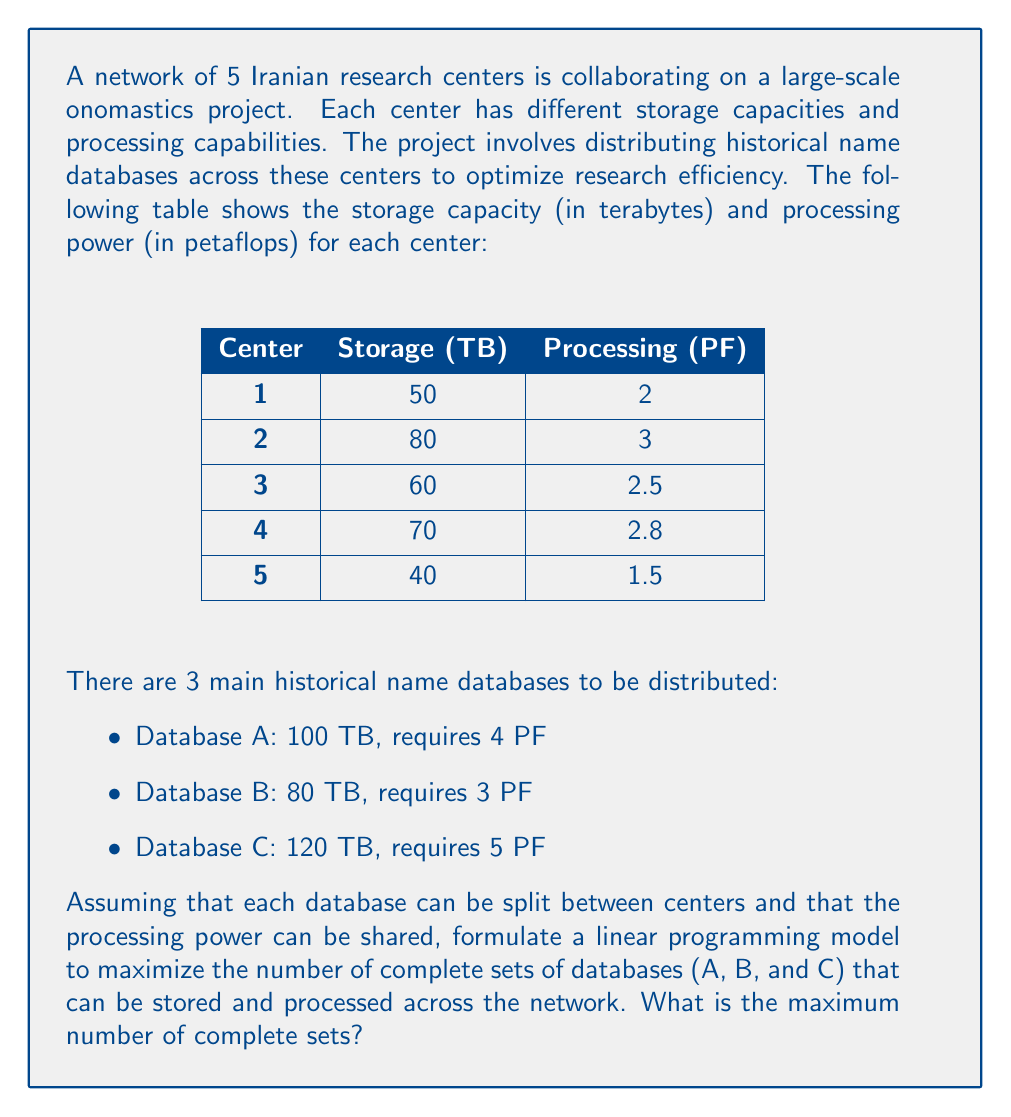What is the answer to this math problem? To solve this problem, we need to formulate a linear programming model and then solve it. Let's go through this step-by-step:

1) Define variables:
   Let $x_i$ be the number of complete sets stored and processed at center $i$ (where $i = 1, 2, 3, 4, 5$)

2) Objective function:
   Maximize the total number of complete sets:
   $$\text{Maximize } Z = x_1 + x_2 + x_3 + x_4 + x_5$$

3) Constraints:
   a) Storage constraints for each center:
      Center 1: $100x_1 + 80x_1 + 120x_1 \leq 50$
      Center 2: $100x_2 + 80x_2 + 120x_2 \leq 80$
      Center 3: $100x_3 + 80x_3 + 120x_3 \leq 60$
      Center 4: $100x_4 + 80x_4 + 120x_4 \leq 70$
      Center 5: $100x_5 + 80x_5 + 120x_5 \leq 40$

   b) Processing power constraints for each center:
      Center 1: $4x_1 + 3x_1 + 5x_1 \leq 2$
      Center 2: $4x_2 + 3x_2 + 5x_2 \leq 3$
      Center 3: $4x_3 + 3x_3 + 5x_3 \leq 2.5$
      Center 4: $4x_4 + 3x_4 + 5x_4 \leq 2.8$
      Center 5: $4x_5 + 3x_5 + 5x_5 \leq 1.5$

   c) Non-negativity constraints:
      $x_1, x_2, x_3, x_4, x_5 \geq 0$

4) Simplify the constraints:
   a) Storage constraints:
      Center 1: $300x_1 \leq 50$
      Center 2: $300x_2 \leq 80$
      Center 3: $300x_3 \leq 60$
      Center 4: $300x_4 \leq 70$
      Center 5: $300x_5 \leq 40$

   b) Processing power constraints:
      Center 1: $12x_1 \leq 2$
      Center 2: $12x_2 \leq 3$
      Center 3: $12x_3 \leq 2.5$
      Center 4: $12x_4 \leq 2.8$
      Center 5: $12x_5 \leq 1.5$

5) Solve the linear programming problem:
   We can solve this by looking at the most restrictive constraint for each center:

   Center 1: $x_1 \leq \min(\frac{50}{300}, \frac{2}{12}) = \frac{1}{6}$
   Center 2: $x_2 \leq \min(\frac{80}{300}, \frac{3}{12}) = \frac{1}{4}$
   Center 3: $x_3 \leq \min(\frac{60}{300}, \frac{2.5}{12}) = \frac{25}{144} \approx 0.1736$
   Center 4: $x_4 \leq \min(\frac{70}{300}, \frac{2.8}{12}) = \frac{7}{30} \approx 0.2333$
   Center 5: $x_5 \leq \min(\frac{40}{300}, \frac{1.5}{12}) = \frac{1}{8}$

   The maximum value of Z is the sum of these upper bounds:
   $$Z = \frac{1}{6} + \frac{1}{4} + \frac{25}{144} + \frac{7}{30} + \frac{1}{8} \approx 0.9403$$

   Since we can only have whole sets, we round down to 0.
Answer: The maximum number of complete sets of databases (A, B, and C) that can be stored and processed across the network is 0. 